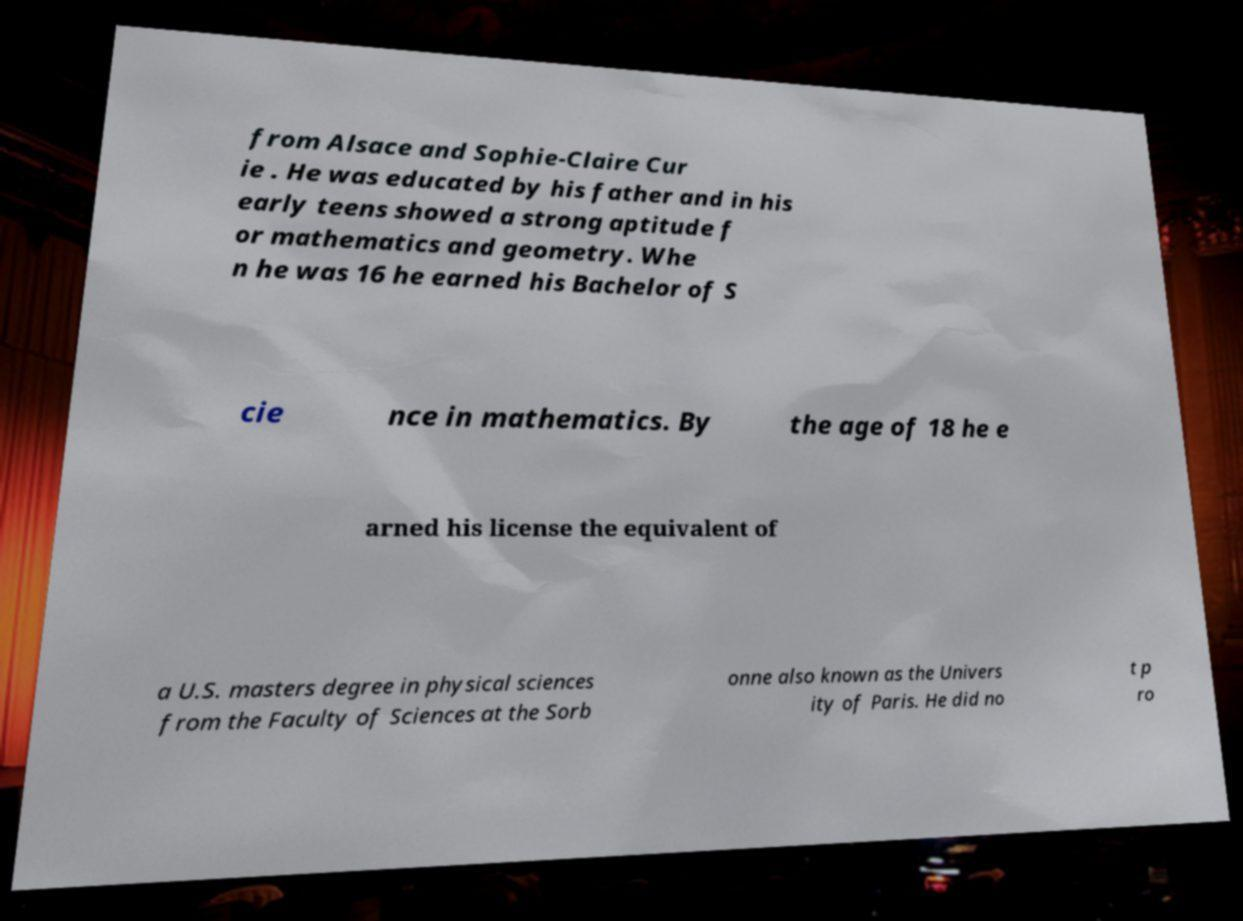Please identify and transcribe the text found in this image. from Alsace and Sophie-Claire Cur ie . He was educated by his father and in his early teens showed a strong aptitude f or mathematics and geometry. Whe n he was 16 he earned his Bachelor of S cie nce in mathematics. By the age of 18 he e arned his license the equivalent of a U.S. masters degree in physical sciences from the Faculty of Sciences at the Sorb onne also known as the Univers ity of Paris. He did no t p ro 